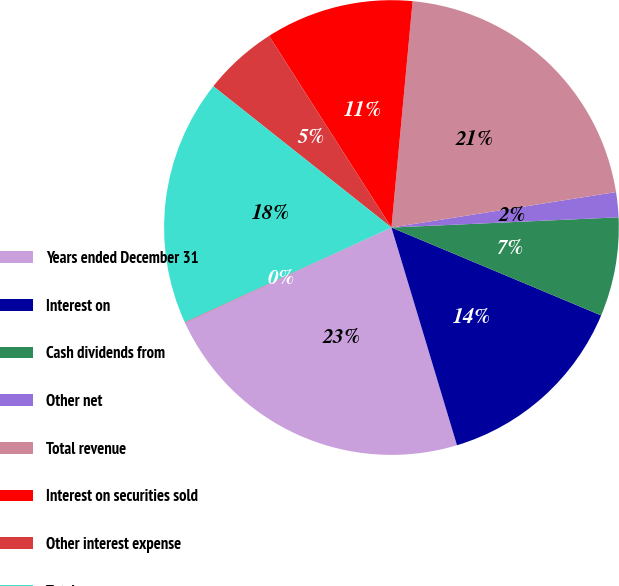Convert chart. <chart><loc_0><loc_0><loc_500><loc_500><pie_chart><fcel>Years ended December 31<fcel>Interest on<fcel>Cash dividends from<fcel>Other net<fcel>Total revenue<fcel>Interest on securities sold<fcel>Other interest expense<fcel>Total expenses<fcel>Income tax expense (benefit)<nl><fcel>22.77%<fcel>14.03%<fcel>7.03%<fcel>1.78%<fcel>21.02%<fcel>10.53%<fcel>5.28%<fcel>17.52%<fcel>0.03%<nl></chart> 